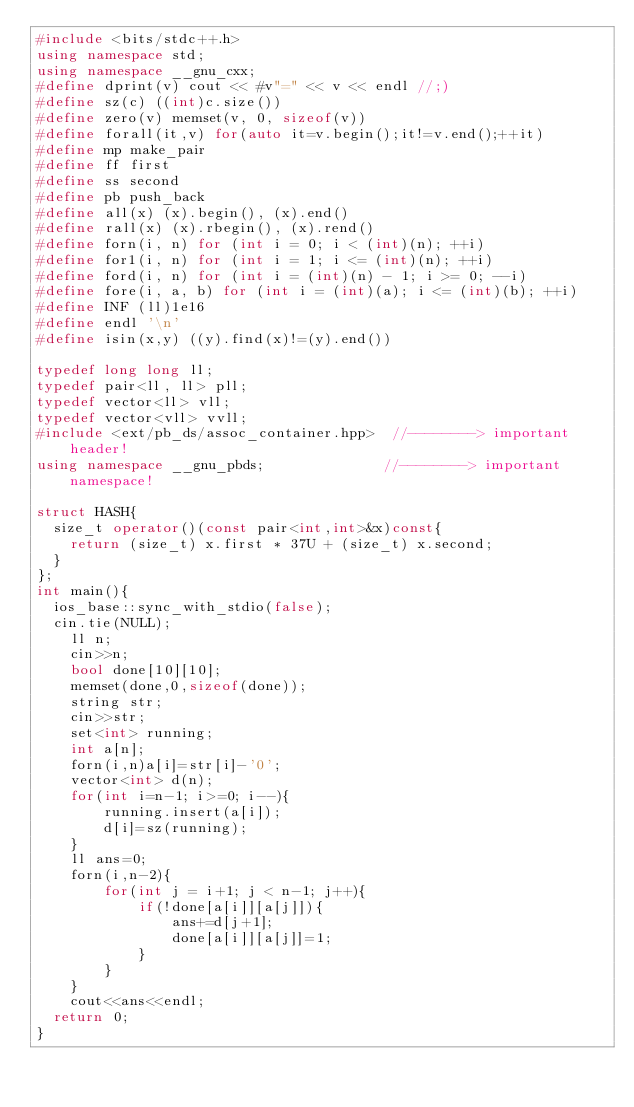<code> <loc_0><loc_0><loc_500><loc_500><_C++_>#include <bits/stdc++.h>
using namespace std;
using namespace __gnu_cxx;
#define dprint(v) cout << #v"=" << v << endl //;)
#define sz(c) ((int)c.size())
#define zero(v) memset(v, 0, sizeof(v))
#define forall(it,v) for(auto it=v.begin();it!=v.end();++it)
#define mp make_pair
#define ff first
#define ss second
#define pb push_back
#define all(x) (x).begin(), (x).end()
#define rall(x) (x).rbegin(), (x).rend()
#define forn(i, n) for (int i = 0; i < (int)(n); ++i)
#define for1(i, n) for (int i = 1; i <= (int)(n); ++i)
#define ford(i, n) for (int i = (int)(n) - 1; i >= 0; --i)
#define fore(i, a, b) for (int i = (int)(a); i <= (int)(b); ++i)
#define INF (ll)1e16
#define endl '\n'
#define isin(x,y) ((y).find(x)!=(y).end())

typedef long long ll;
typedef pair<ll, ll> pll;
typedef vector<ll> vll;
typedef vector<vll> vvll;
#include <ext/pb_ds/assoc_container.hpp>  //--------> important header!
using namespace __gnu_pbds;              //--------> important namespace!

struct HASH{
  size_t operator()(const pair<int,int>&x)const{
    return (size_t) x.first * 37U + (size_t) x.second;
  }
};
int main(){
	ios_base::sync_with_stdio(false);
	cin.tie(NULL);
    ll n;
    cin>>n;
    bool done[10][10];
    memset(done,0,sizeof(done));
    string str;
    cin>>str;
    set<int> running;
    int a[n];
    forn(i,n)a[i]=str[i]-'0';
    vector<int> d(n);
    for(int i=n-1; i>=0; i--){
        running.insert(a[i]);
        d[i]=sz(running);
    }
    ll ans=0;
    forn(i,n-2){
        for(int j = i+1; j < n-1; j++){
            if(!done[a[i]][a[j]]){
                ans+=d[j+1];
                done[a[i]][a[j]]=1;
            }
        }
    }
    cout<<ans<<endl;
	return 0;
}
</code> 